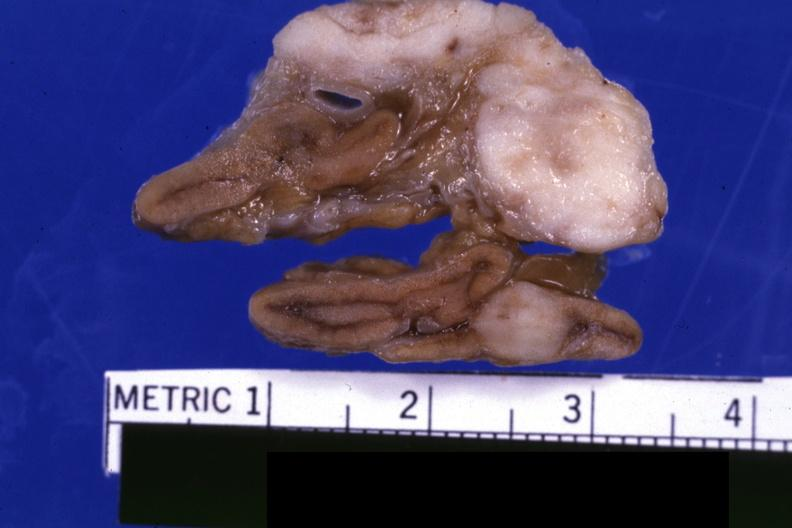where does this belong to?
Answer the question using a single word or phrase. Endocrine system 